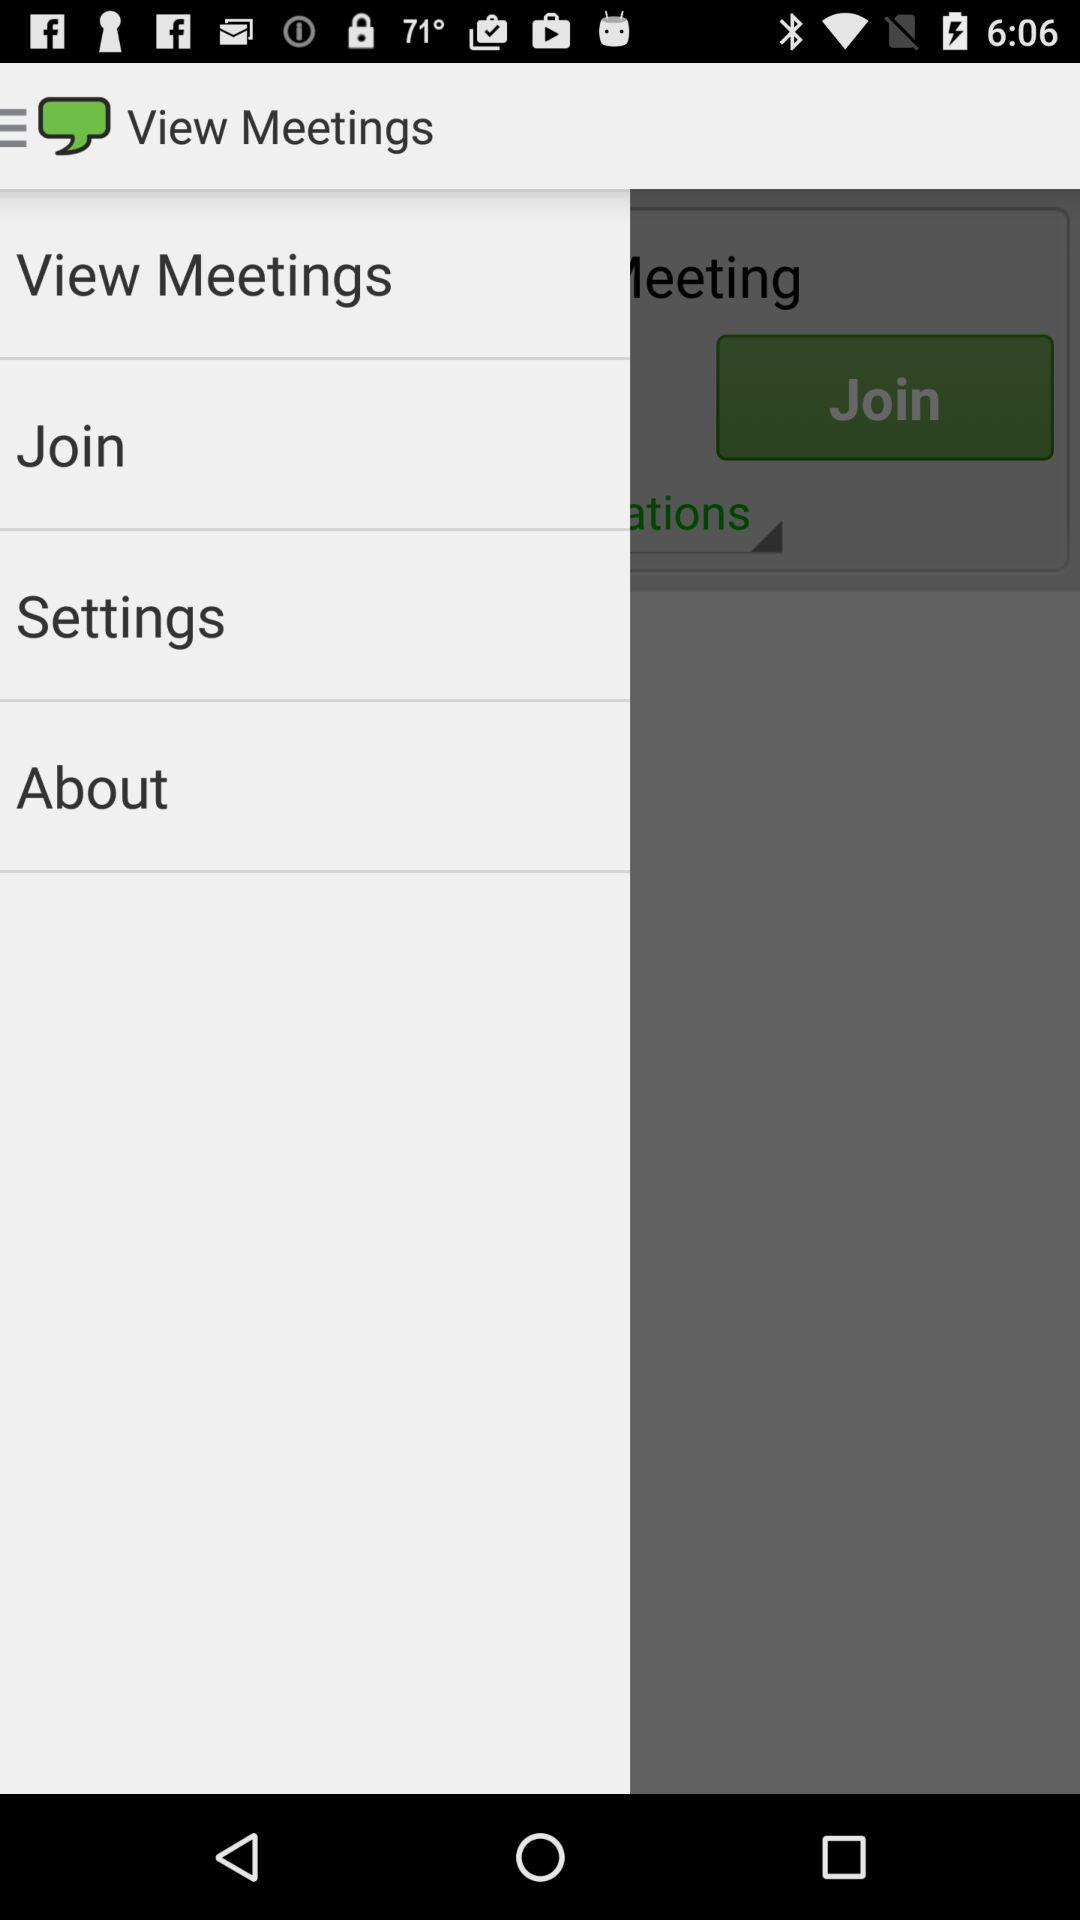What is the name of the application? The name of the application is "View Meetings". 